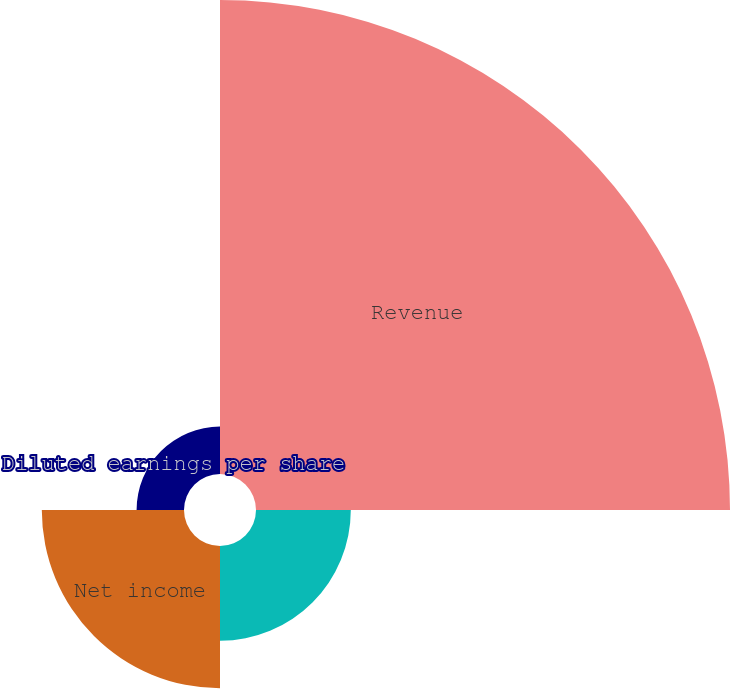<chart> <loc_0><loc_0><loc_500><loc_500><pie_chart><fcel>Revenue<fcel>Income before cumulative<fcel>Net income<fcel>Diluted earnings per share<nl><fcel>62.5%<fcel>12.5%<fcel>18.75%<fcel>6.25%<nl></chart> 